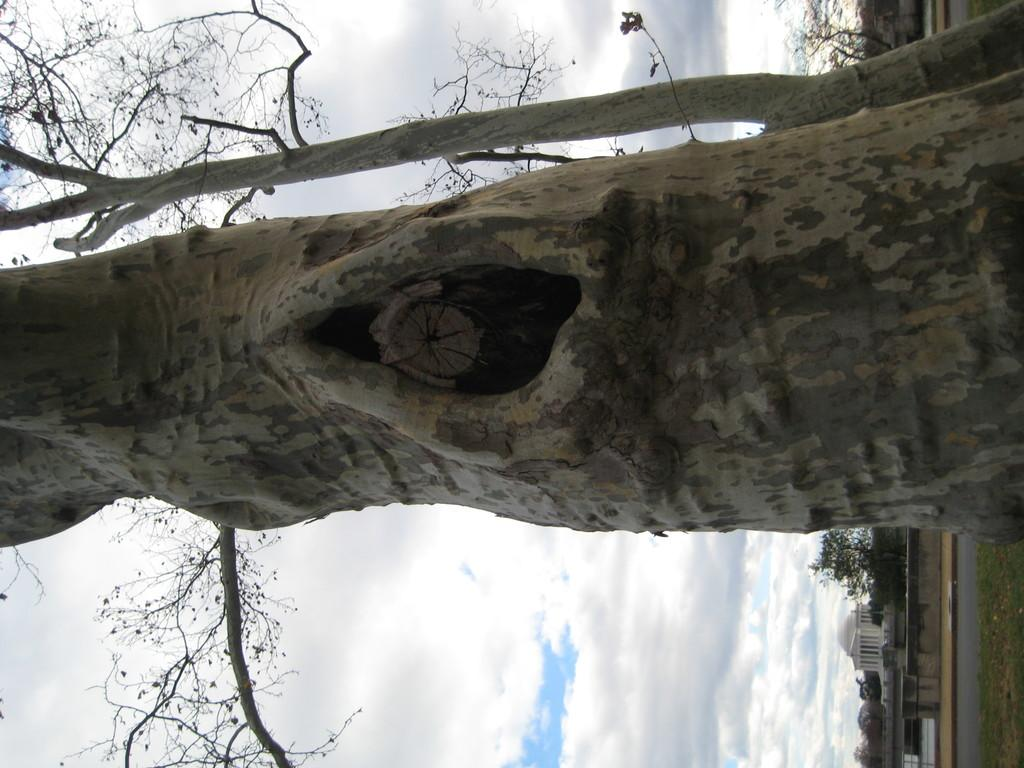What is the main feature of the tree in the image? There is a tree with a hole in the image. Can you describe the background of the image? There is another tree in the background of the image. What can be seen in the sky in the image? The sky is visible in the image, and there are clouds in the sky. What type of man-made structures are present in the image? There are buildings in the image. What type of pathway is visible in the image? There is a road in the image. What type of yoke is being used to plough the field in the image? There is no field or ploughing activity present in the image. What type of bait is being used to catch fish in the image? There is no fishing activity or bait present in the image. 